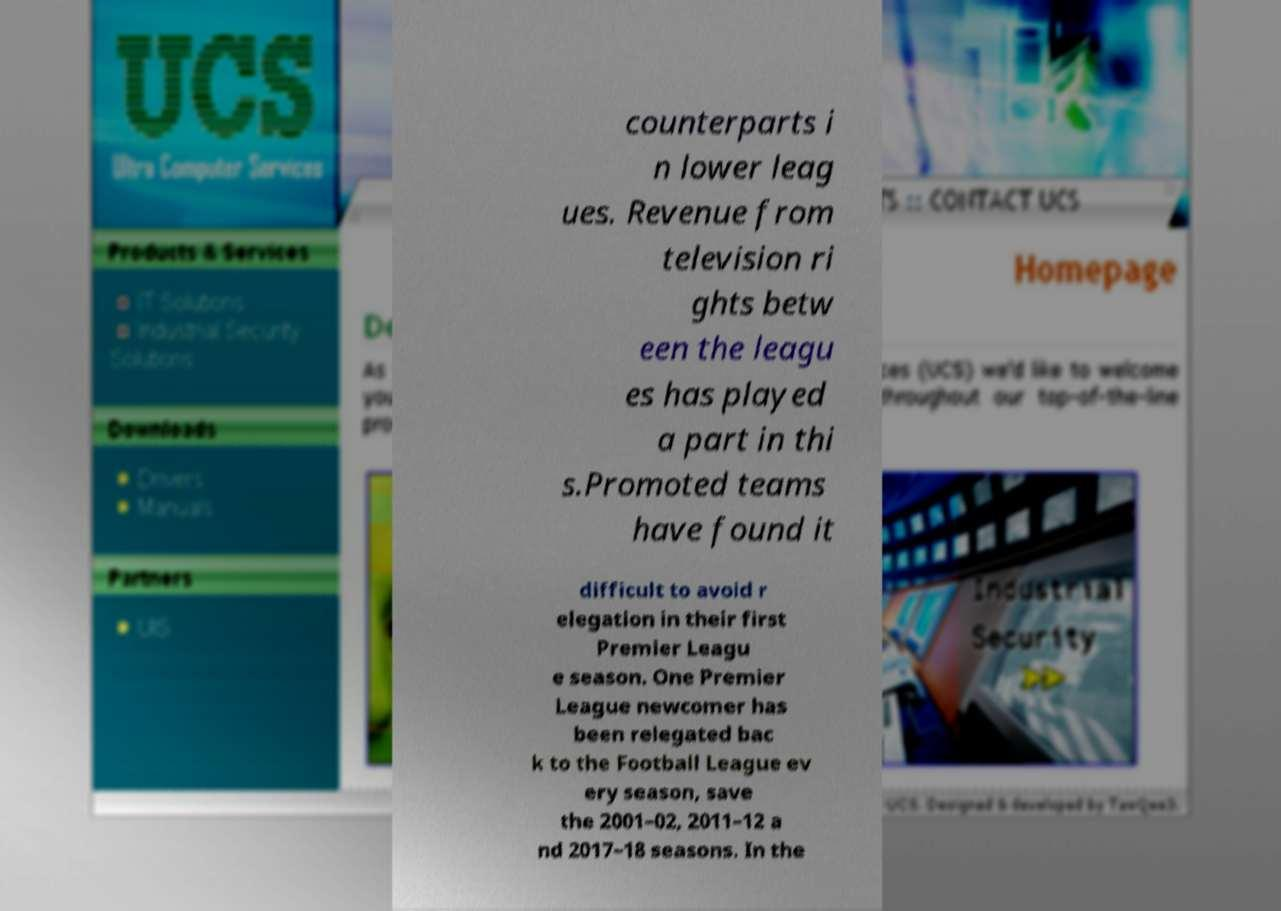I need the written content from this picture converted into text. Can you do that? counterparts i n lower leag ues. Revenue from television ri ghts betw een the leagu es has played a part in thi s.Promoted teams have found it difficult to avoid r elegation in their first Premier Leagu e season. One Premier League newcomer has been relegated bac k to the Football League ev ery season, save the 2001–02, 2011–12 a nd 2017–18 seasons. In the 